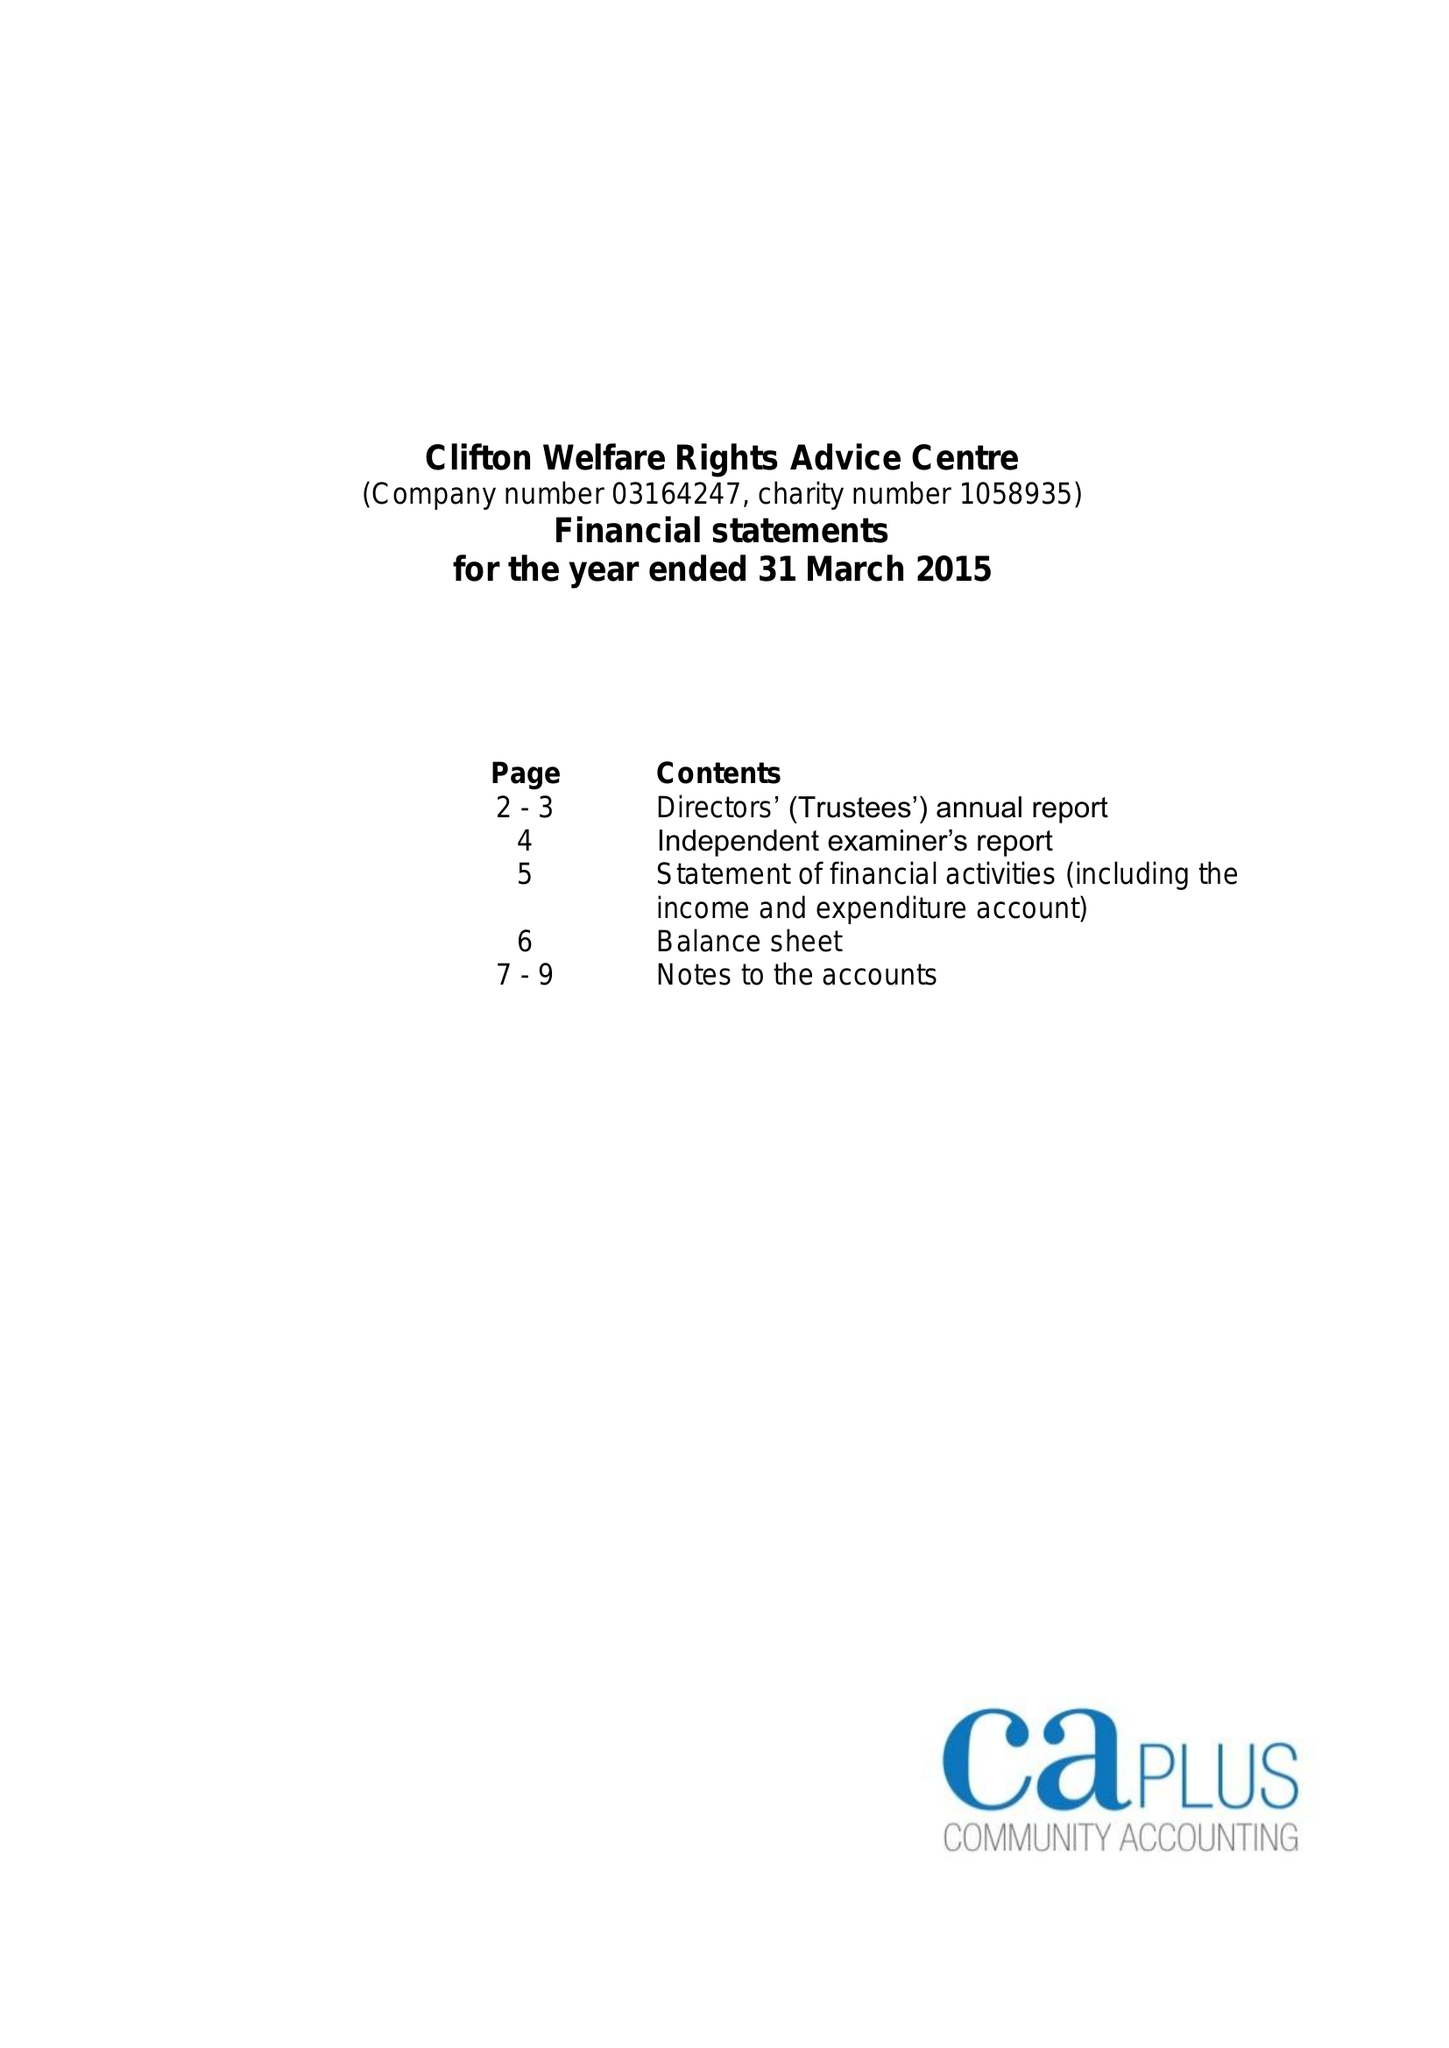What is the value for the charity_name?
Answer the question using a single word or phrase. Clifton Welfare Rights Advice Centre 